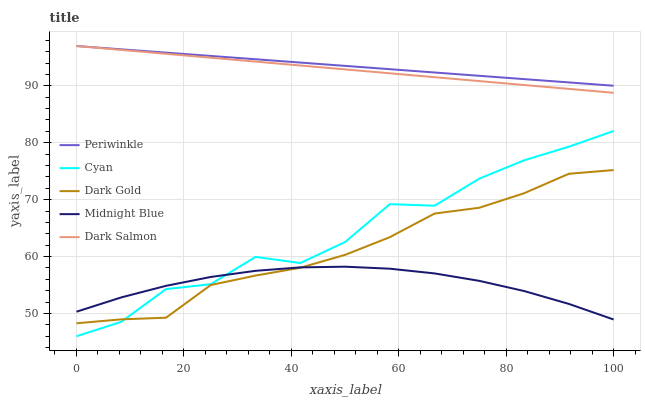Does Midnight Blue have the minimum area under the curve?
Answer yes or no. Yes. Does Periwinkle have the maximum area under the curve?
Answer yes or no. Yes. Does Dark Salmon have the minimum area under the curve?
Answer yes or no. No. Does Dark Salmon have the maximum area under the curve?
Answer yes or no. No. Is Periwinkle the smoothest?
Answer yes or no. Yes. Is Cyan the roughest?
Answer yes or no. Yes. Is Dark Salmon the smoothest?
Answer yes or no. No. Is Dark Salmon the roughest?
Answer yes or no. No. Does Cyan have the lowest value?
Answer yes or no. Yes. Does Dark Salmon have the lowest value?
Answer yes or no. No. Does Periwinkle have the highest value?
Answer yes or no. Yes. Does Midnight Blue have the highest value?
Answer yes or no. No. Is Dark Gold less than Periwinkle?
Answer yes or no. Yes. Is Dark Salmon greater than Cyan?
Answer yes or no. Yes. Does Cyan intersect Midnight Blue?
Answer yes or no. Yes. Is Cyan less than Midnight Blue?
Answer yes or no. No. Is Cyan greater than Midnight Blue?
Answer yes or no. No. Does Dark Gold intersect Periwinkle?
Answer yes or no. No. 